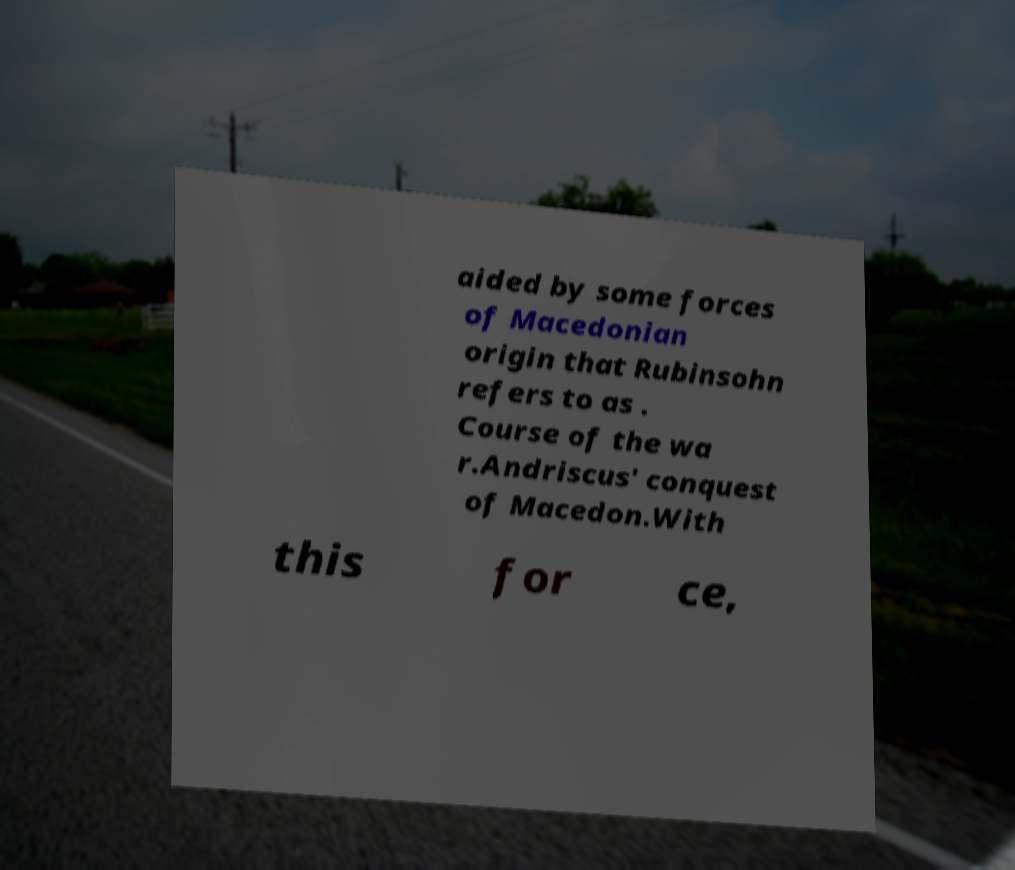Please read and relay the text visible in this image. What does it say? aided by some forces of Macedonian origin that Rubinsohn refers to as . Course of the wa r.Andriscus' conquest of Macedon.With this for ce, 